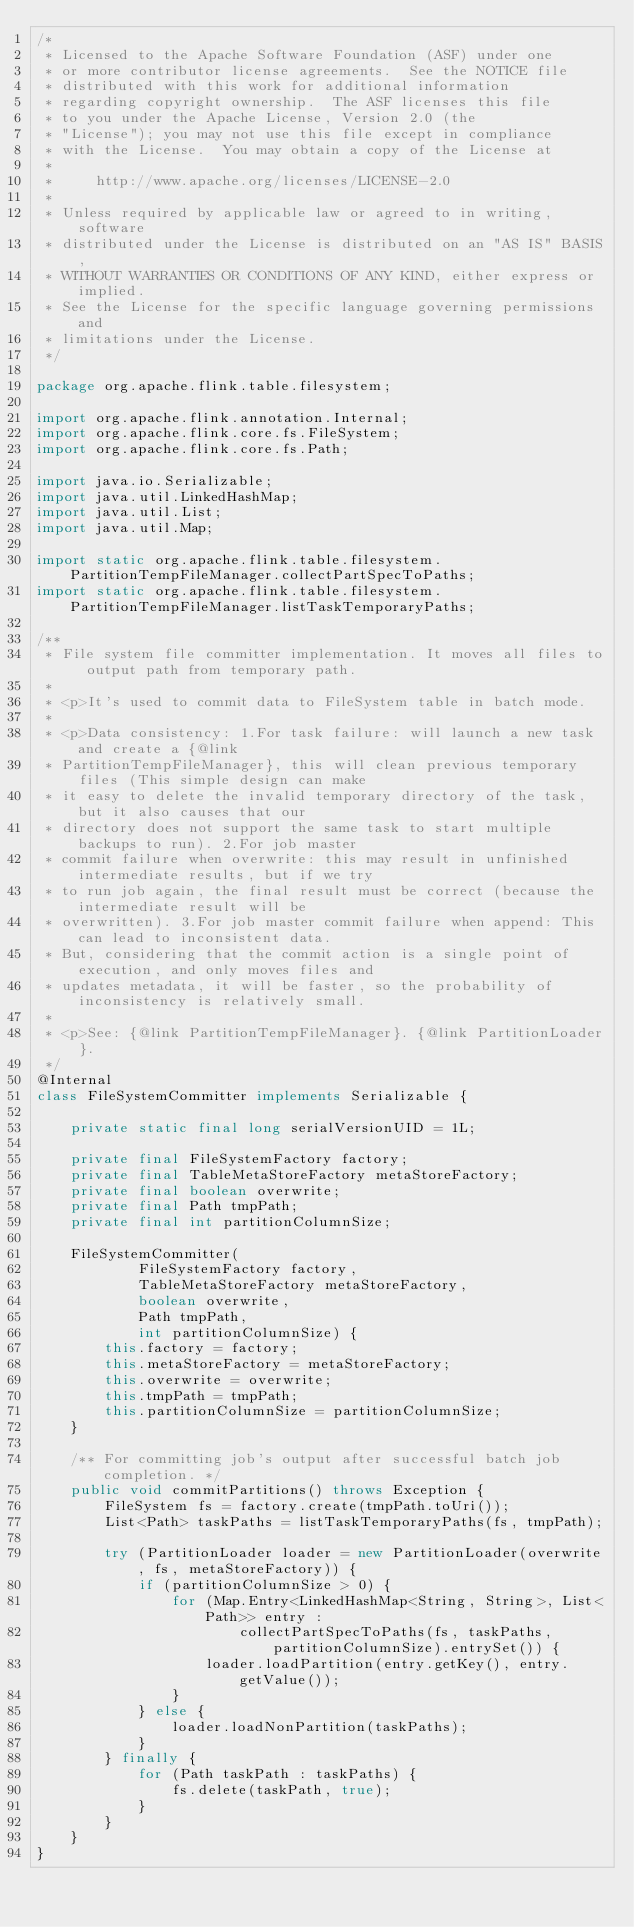Convert code to text. <code><loc_0><loc_0><loc_500><loc_500><_Java_>/*
 * Licensed to the Apache Software Foundation (ASF) under one
 * or more contributor license agreements.  See the NOTICE file
 * distributed with this work for additional information
 * regarding copyright ownership.  The ASF licenses this file
 * to you under the Apache License, Version 2.0 (the
 * "License"); you may not use this file except in compliance
 * with the License.  You may obtain a copy of the License at
 *
 *     http://www.apache.org/licenses/LICENSE-2.0
 *
 * Unless required by applicable law or agreed to in writing, software
 * distributed under the License is distributed on an "AS IS" BASIS,
 * WITHOUT WARRANTIES OR CONDITIONS OF ANY KIND, either express or implied.
 * See the License for the specific language governing permissions and
 * limitations under the License.
 */

package org.apache.flink.table.filesystem;

import org.apache.flink.annotation.Internal;
import org.apache.flink.core.fs.FileSystem;
import org.apache.flink.core.fs.Path;

import java.io.Serializable;
import java.util.LinkedHashMap;
import java.util.List;
import java.util.Map;

import static org.apache.flink.table.filesystem.PartitionTempFileManager.collectPartSpecToPaths;
import static org.apache.flink.table.filesystem.PartitionTempFileManager.listTaskTemporaryPaths;

/**
 * File system file committer implementation. It moves all files to output path from temporary path.
 *
 * <p>It's used to commit data to FileSystem table in batch mode.
 *
 * <p>Data consistency: 1.For task failure: will launch a new task and create a {@link
 * PartitionTempFileManager}, this will clean previous temporary files (This simple design can make
 * it easy to delete the invalid temporary directory of the task, but it also causes that our
 * directory does not support the same task to start multiple backups to run). 2.For job master
 * commit failure when overwrite: this may result in unfinished intermediate results, but if we try
 * to run job again, the final result must be correct (because the intermediate result will be
 * overwritten). 3.For job master commit failure when append: This can lead to inconsistent data.
 * But, considering that the commit action is a single point of execution, and only moves files and
 * updates metadata, it will be faster, so the probability of inconsistency is relatively small.
 *
 * <p>See: {@link PartitionTempFileManager}. {@link PartitionLoader}.
 */
@Internal
class FileSystemCommitter implements Serializable {

    private static final long serialVersionUID = 1L;

    private final FileSystemFactory factory;
    private final TableMetaStoreFactory metaStoreFactory;
    private final boolean overwrite;
    private final Path tmpPath;
    private final int partitionColumnSize;

    FileSystemCommitter(
            FileSystemFactory factory,
            TableMetaStoreFactory metaStoreFactory,
            boolean overwrite,
            Path tmpPath,
            int partitionColumnSize) {
        this.factory = factory;
        this.metaStoreFactory = metaStoreFactory;
        this.overwrite = overwrite;
        this.tmpPath = tmpPath;
        this.partitionColumnSize = partitionColumnSize;
    }

    /** For committing job's output after successful batch job completion. */
    public void commitPartitions() throws Exception {
        FileSystem fs = factory.create(tmpPath.toUri());
        List<Path> taskPaths = listTaskTemporaryPaths(fs, tmpPath);

        try (PartitionLoader loader = new PartitionLoader(overwrite, fs, metaStoreFactory)) {
            if (partitionColumnSize > 0) {
                for (Map.Entry<LinkedHashMap<String, String>, List<Path>> entry :
                        collectPartSpecToPaths(fs, taskPaths, partitionColumnSize).entrySet()) {
                    loader.loadPartition(entry.getKey(), entry.getValue());
                }
            } else {
                loader.loadNonPartition(taskPaths);
            }
        } finally {
            for (Path taskPath : taskPaths) {
                fs.delete(taskPath, true);
            }
        }
    }
}
</code> 